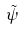Convert formula to latex. <formula><loc_0><loc_0><loc_500><loc_500>\tilde { \psi }</formula> 